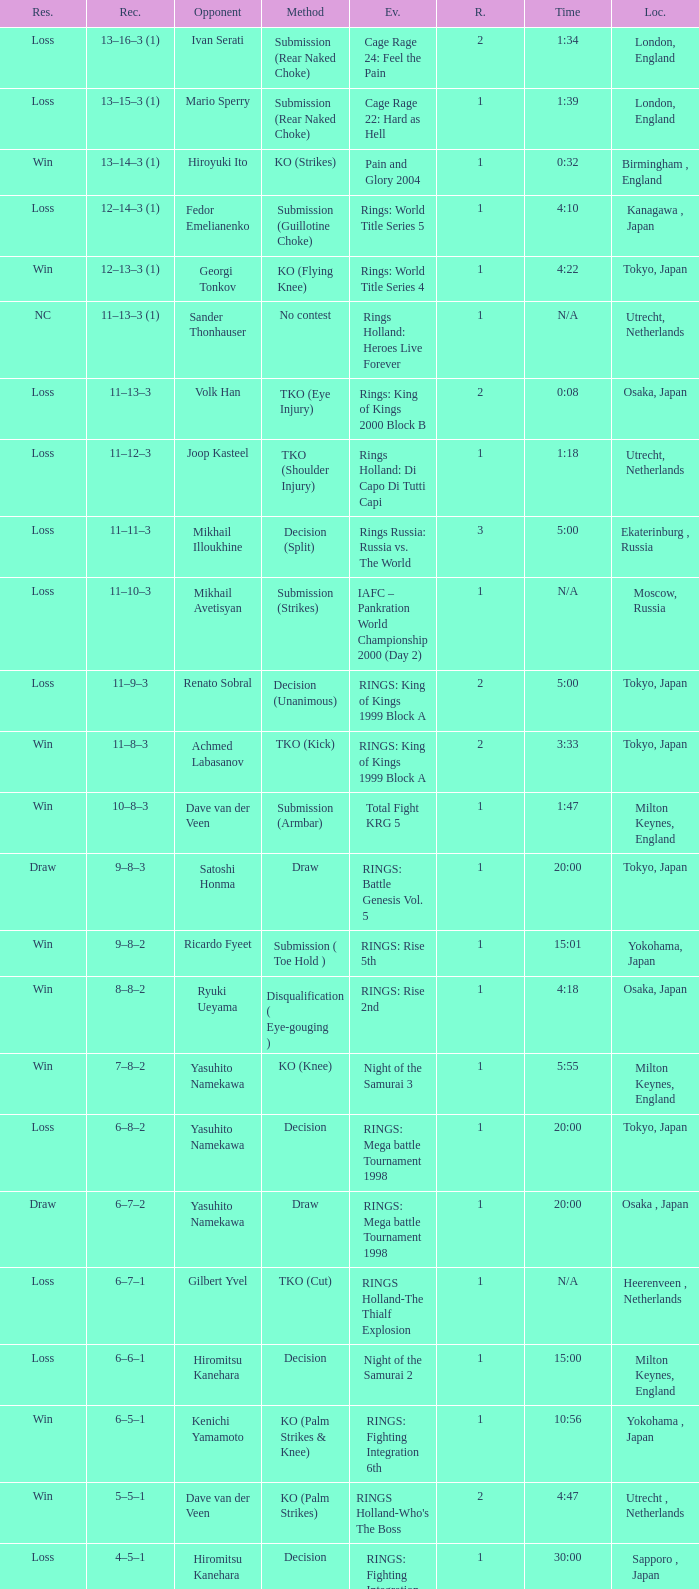What event featured yasuhito namekawa's opponent and utilized a decision method? RINGS: Mega battle Tournament 1998. 